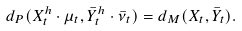<formula> <loc_0><loc_0><loc_500><loc_500>d _ { P } ( X ^ { h } _ { t } \cdot \mu _ { t } , \bar { Y } ^ { h } _ { t } \cdot \bar { \nu } _ { t } ) = d _ { M } ( X _ { t } , \bar { Y } _ { t } ) .</formula> 